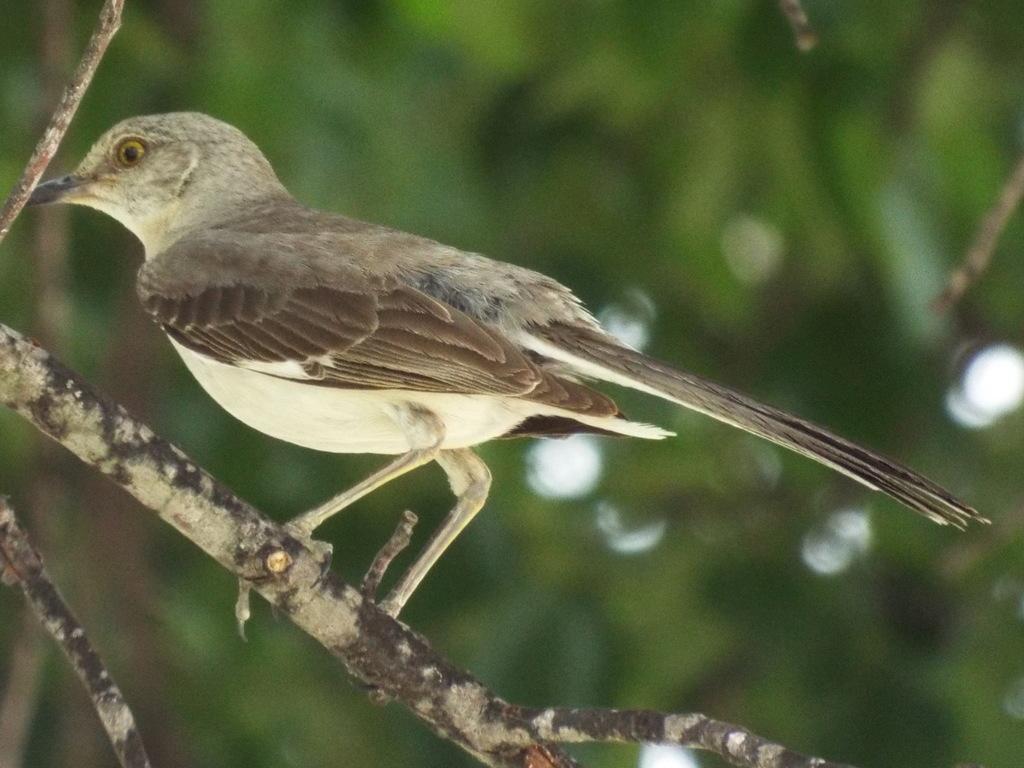How would you summarize this image in a sentence or two? In this picture there is a bird who is standing on the tree branch. In the background it might be the tree and I can see the blur image. 